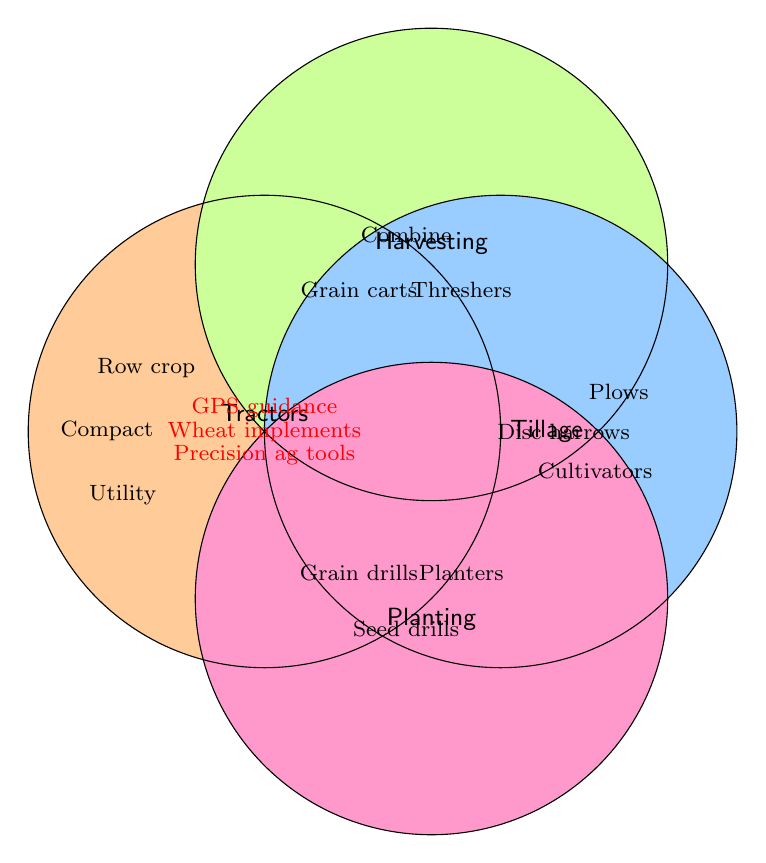What color represents Tractors in the diagram? The color of the section for 'Tractors' is a light shade.
Answer: Light shade Which category contains Combine harvesters? Combine harvesters are placed in the section labeled 'Harvesting'.
Answer: Harvesting How many items are listed under the Tillage category? There are three items within the 'Tillage' section: Plows, Cultivators, and Disc harrows.
Answer: Three Name an item that falls under all categories. An item that is in the shared area of all four circles. There are three: GPS guidance systems, Precision agriculture tools, and Implements for wheat cultivation.
Answer: GPS guidance systems Are there more categories under Planting or Tillage? Both 'Planting' and 'Tillage' categories contain the same number of items, each with three listed.
Answer: Equal Which category is less populated, Tractors or Harvesting? Both 'Tractors' and 'Harvesting' have the same number of items, with three each.
Answer: Equal Which specific machines are included under Planting? Checking the 'Planting' section, the machines listed are Seed drills, Planters, and Grain drills.
Answer: Seed drills, Planters, Grain drills Do Precision agriculture tools belong to the Tractors category? Precision agriculture tools fall under 'All' categories, which includes Tractors.
Answer: Yes Compare the number of items listed under Tractors and Harvesting versus Tillage and Planting combined. Tractors (3) and Harvesting (3) total six items; Tillage (3) and Planting (3) also total six items.
Answer: Equal Are there more unique items or shared items (those listed under 'All') in the figure? Unique items: Tractors (3), Harvesting (3), Tillage (3), Planting (3) total 12 unique items. Shared items include 3 (under 'All'). 12 unique is greater than 3 shared.
Answer: More unique 